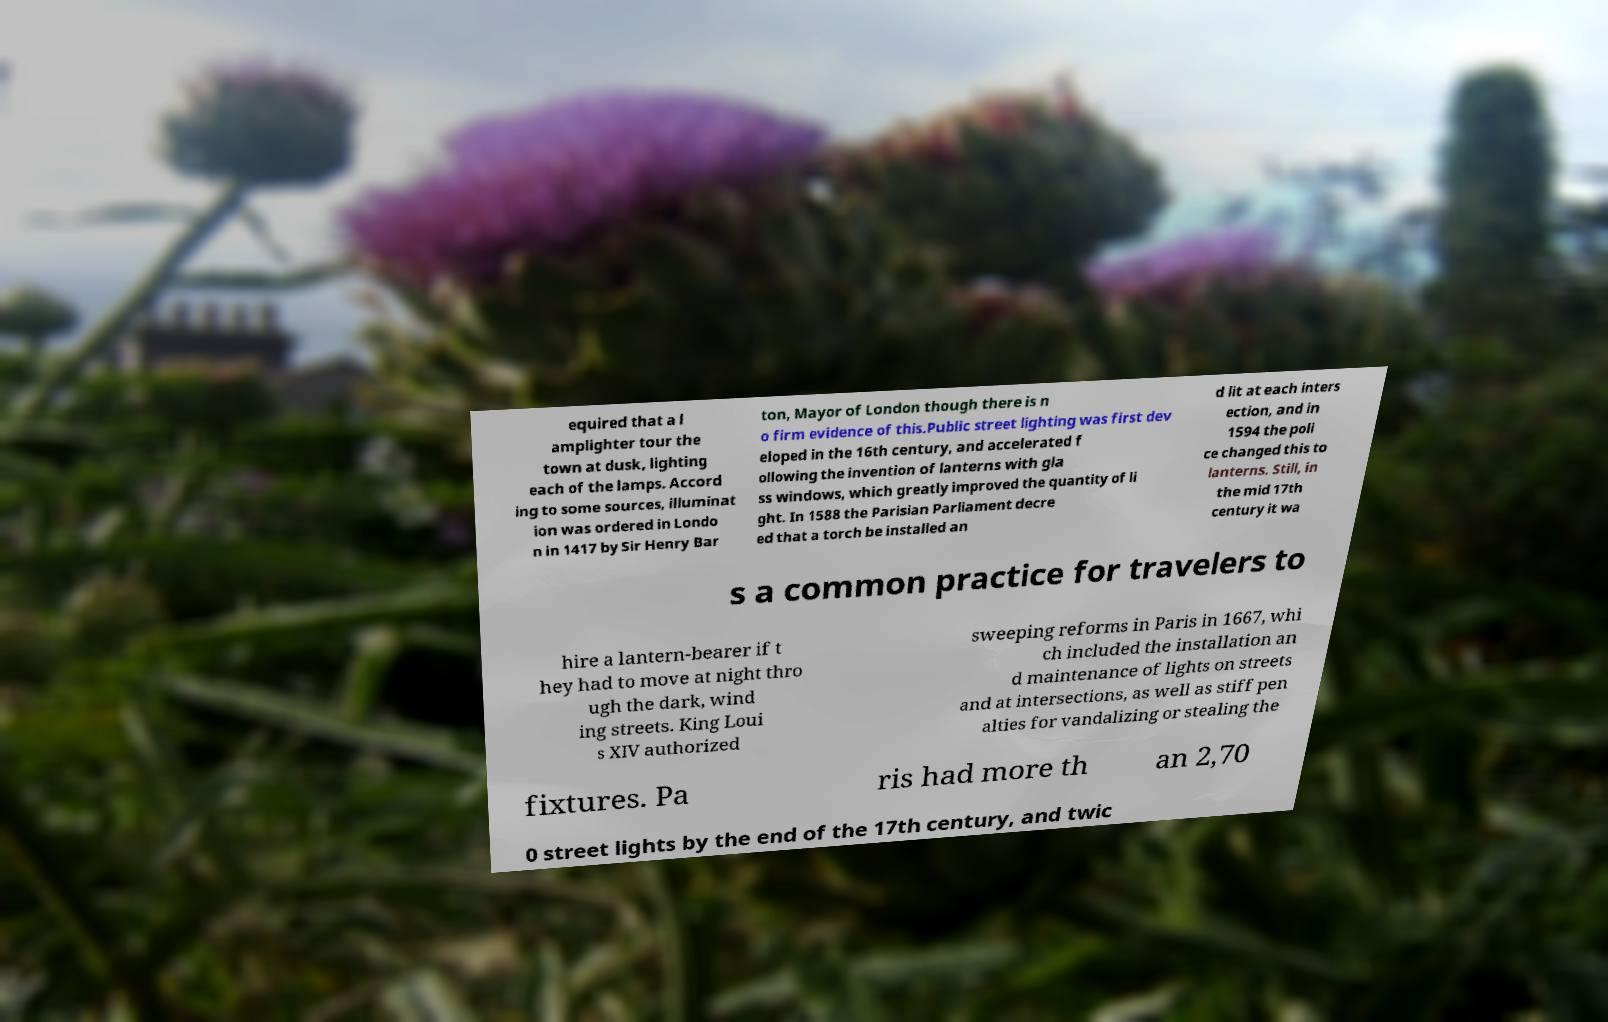Can you accurately transcribe the text from the provided image for me? equired that a l amplighter tour the town at dusk, lighting each of the lamps. Accord ing to some sources, illuminat ion was ordered in Londo n in 1417 by Sir Henry Bar ton, Mayor of London though there is n o firm evidence of this.Public street lighting was first dev eloped in the 16th century, and accelerated f ollowing the invention of lanterns with gla ss windows, which greatly improved the quantity of li ght. In 1588 the Parisian Parliament decre ed that a torch be installed an d lit at each inters ection, and in 1594 the poli ce changed this to lanterns. Still, in the mid 17th century it wa s a common practice for travelers to hire a lantern-bearer if t hey had to move at night thro ugh the dark, wind ing streets. King Loui s XIV authorized sweeping reforms in Paris in 1667, whi ch included the installation an d maintenance of lights on streets and at intersections, as well as stiff pen alties for vandalizing or stealing the fixtures. Pa ris had more th an 2,70 0 street lights by the end of the 17th century, and twic 